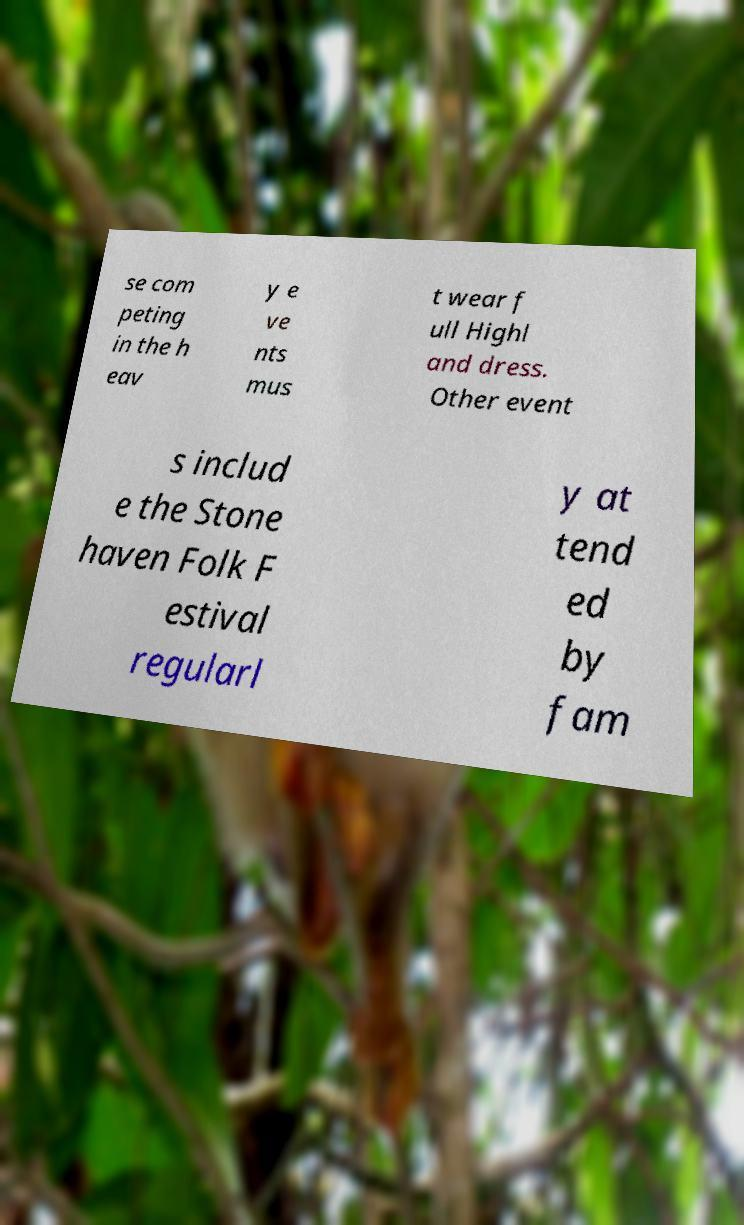Can you accurately transcribe the text from the provided image for me? se com peting in the h eav y e ve nts mus t wear f ull Highl and dress. Other event s includ e the Stone haven Folk F estival regularl y at tend ed by fam 